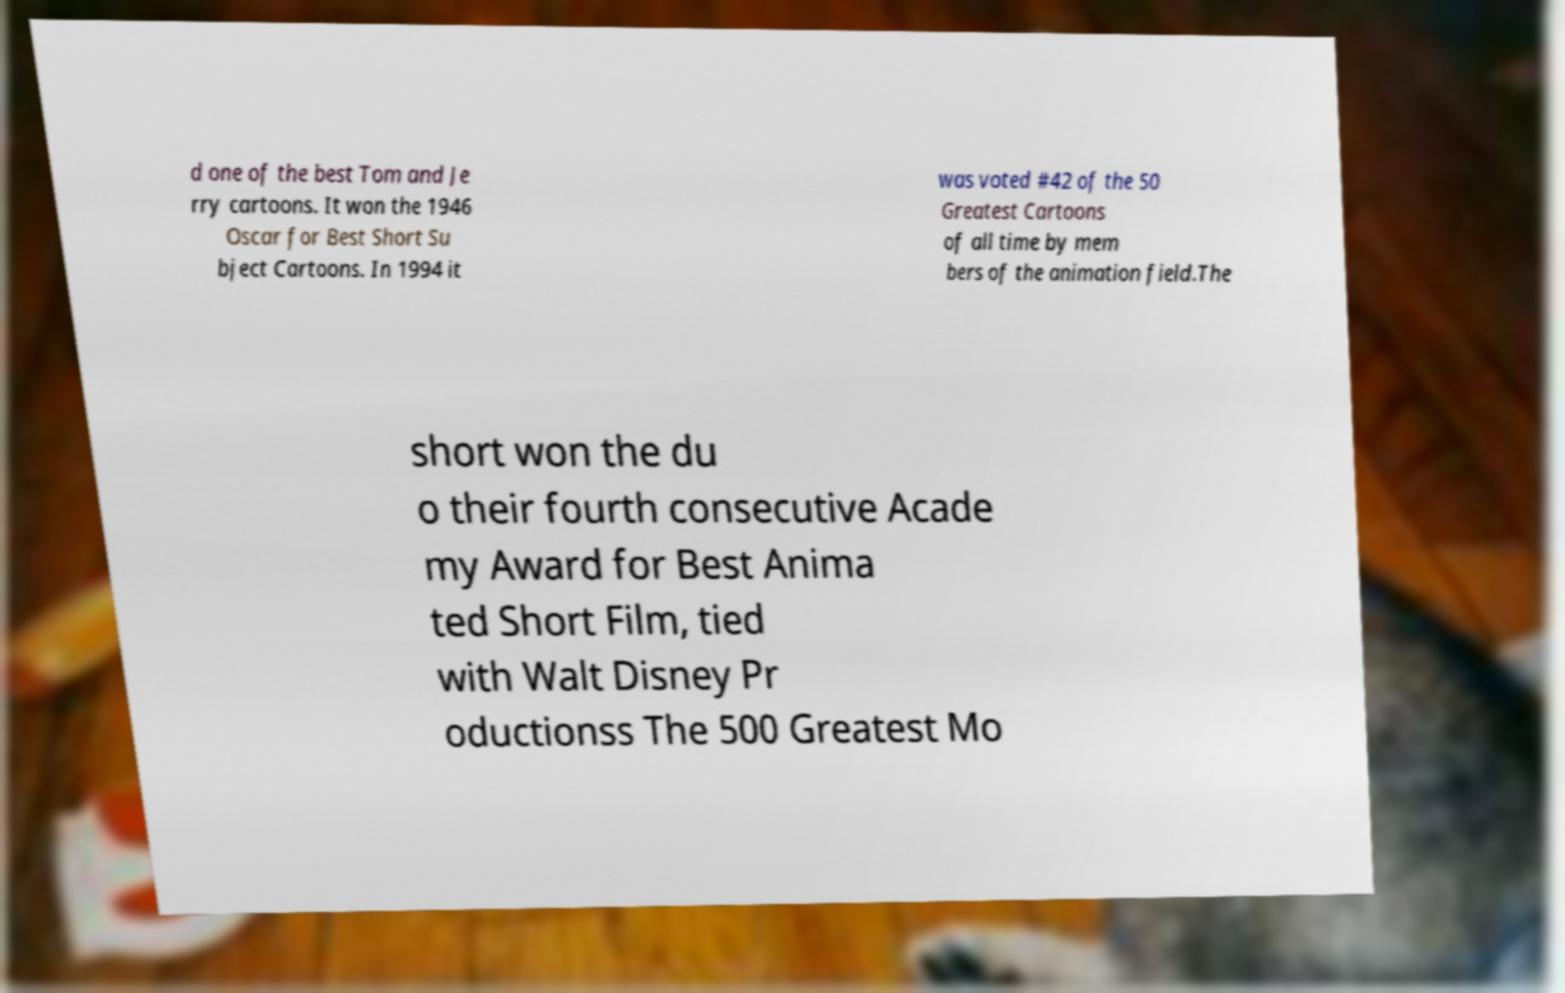Could you assist in decoding the text presented in this image and type it out clearly? d one of the best Tom and Je rry cartoons. It won the 1946 Oscar for Best Short Su bject Cartoons. In 1994 it was voted #42 of the 50 Greatest Cartoons of all time by mem bers of the animation field.The short won the du o their fourth consecutive Acade my Award for Best Anima ted Short Film, tied with Walt Disney Pr oductionss The 500 Greatest Mo 